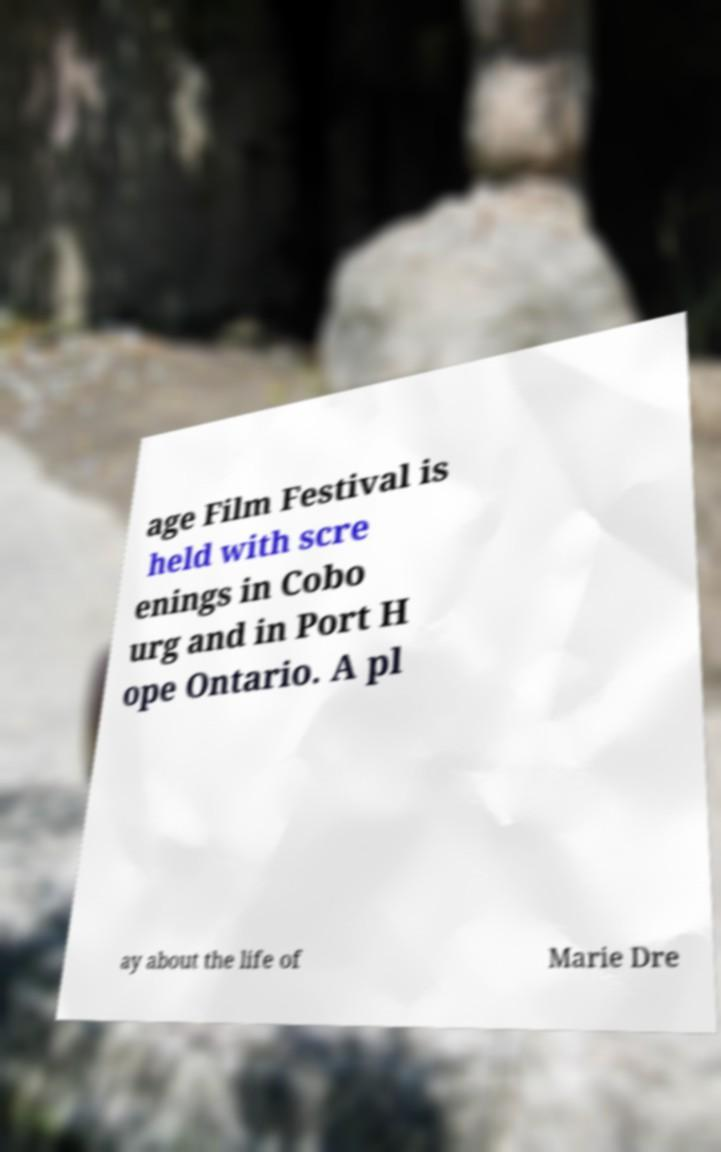Can you read and provide the text displayed in the image?This photo seems to have some interesting text. Can you extract and type it out for me? age Film Festival is held with scre enings in Cobo urg and in Port H ope Ontario. A pl ay about the life of Marie Dre 